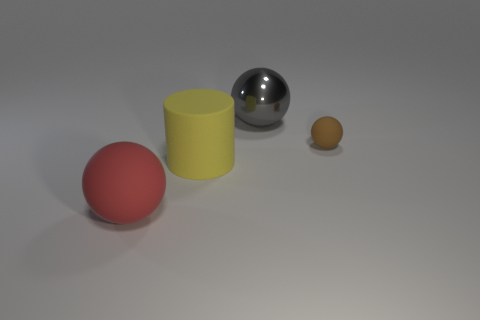Is there any other thing that is the same shape as the yellow rubber object?
Your answer should be compact. No. Does the brown sphere have the same material as the large ball that is to the left of the gray metallic ball?
Ensure brevity in your answer.  Yes. What number of brown objects are either tiny rubber spheres or large matte cylinders?
Offer a very short reply. 1. Are any small red cylinders visible?
Offer a terse response. No. There is a rubber ball that is to the left of the large matte thing that is to the right of the large red object; are there any large metallic things that are on the right side of it?
Your response must be concise. Yes. Are there any other things that have the same size as the brown matte thing?
Ensure brevity in your answer.  No. Do the yellow matte thing and the big metal object that is to the right of the large red rubber thing have the same shape?
Keep it short and to the point. No. What color is the rubber sphere to the right of the large rubber cylinder to the right of the large sphere in front of the small brown sphere?
Provide a short and direct response. Brown. What number of objects are matte spheres in front of the brown sphere or rubber spheres that are to the left of the big yellow cylinder?
Keep it short and to the point. 1. How many other things are there of the same color as the cylinder?
Provide a succinct answer. 0. 